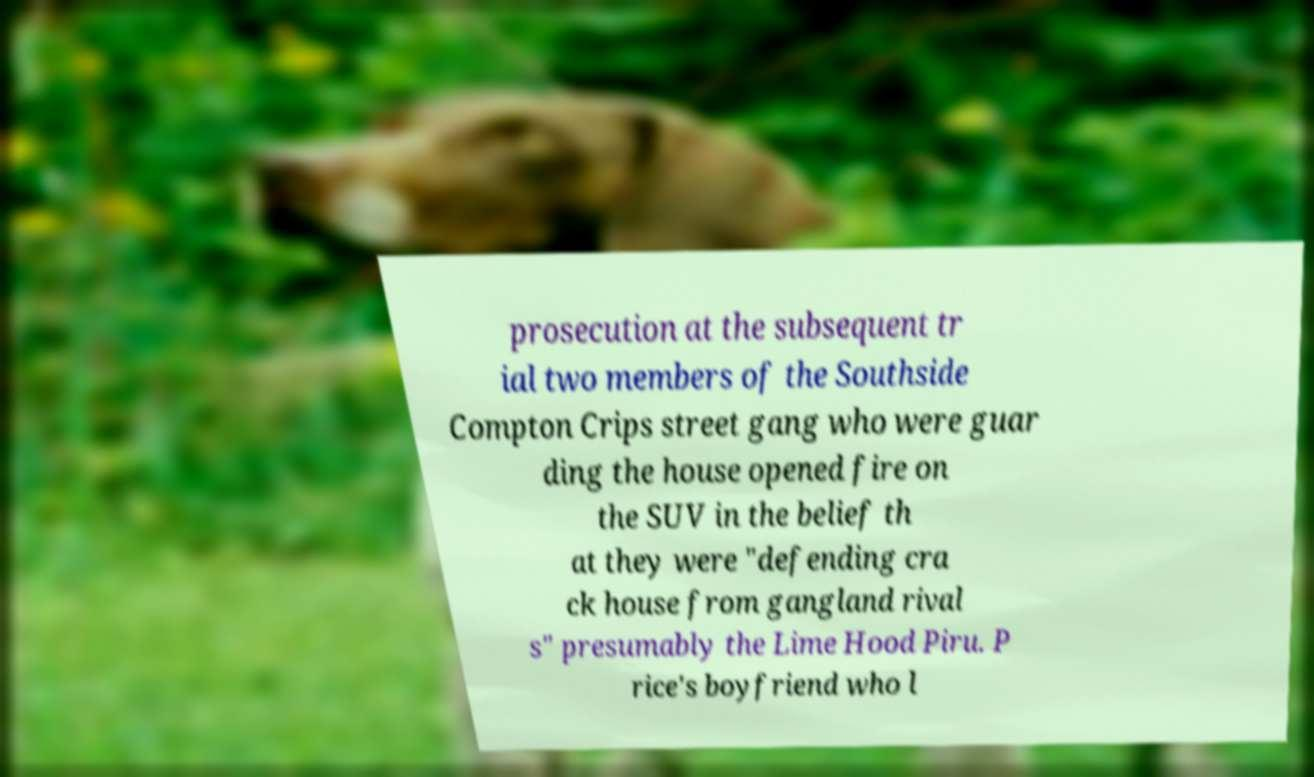Can you accurately transcribe the text from the provided image for me? prosecution at the subsequent tr ial two members of the Southside Compton Crips street gang who were guar ding the house opened fire on the SUV in the belief th at they were "defending cra ck house from gangland rival s" presumably the Lime Hood Piru. P rice's boyfriend who l 